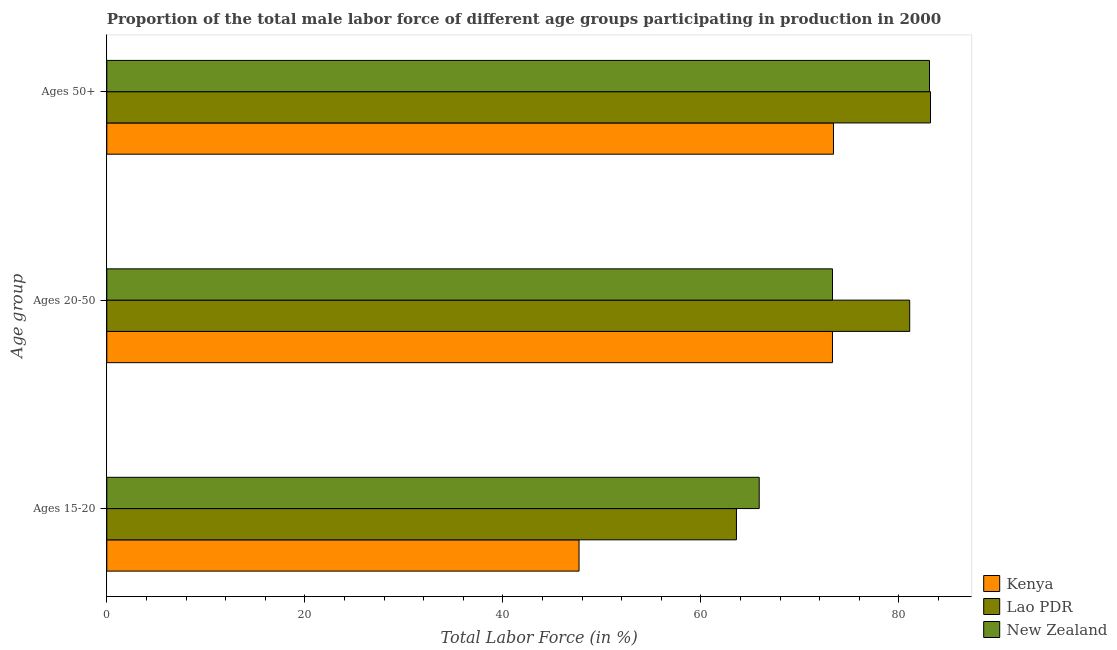How many different coloured bars are there?
Make the answer very short. 3. Are the number of bars per tick equal to the number of legend labels?
Your answer should be very brief. Yes. Are the number of bars on each tick of the Y-axis equal?
Your answer should be compact. Yes. How many bars are there on the 2nd tick from the top?
Ensure brevity in your answer.  3. What is the label of the 3rd group of bars from the top?
Offer a very short reply. Ages 15-20. What is the percentage of male labor force within the age group 15-20 in Lao PDR?
Your answer should be very brief. 63.6. Across all countries, what is the maximum percentage of male labor force above age 50?
Make the answer very short. 83.2. Across all countries, what is the minimum percentage of male labor force above age 50?
Give a very brief answer. 73.4. In which country was the percentage of male labor force within the age group 15-20 maximum?
Provide a succinct answer. New Zealand. In which country was the percentage of male labor force within the age group 15-20 minimum?
Offer a terse response. Kenya. What is the total percentage of male labor force above age 50 in the graph?
Your answer should be compact. 239.7. What is the difference between the percentage of male labor force above age 50 in New Zealand and that in Lao PDR?
Make the answer very short. -0.1. What is the difference between the percentage of male labor force above age 50 in New Zealand and the percentage of male labor force within the age group 15-20 in Kenya?
Provide a short and direct response. 35.4. What is the average percentage of male labor force within the age group 15-20 per country?
Offer a terse response. 59.07. What is the difference between the percentage of male labor force above age 50 and percentage of male labor force within the age group 20-50 in New Zealand?
Your answer should be compact. 9.8. What is the ratio of the percentage of male labor force above age 50 in New Zealand to that in Lao PDR?
Offer a terse response. 1. What is the difference between the highest and the second highest percentage of male labor force above age 50?
Your answer should be very brief. 0.1. What is the difference between the highest and the lowest percentage of male labor force within the age group 20-50?
Ensure brevity in your answer.  7.8. Is the sum of the percentage of male labor force within the age group 20-50 in Lao PDR and Kenya greater than the maximum percentage of male labor force above age 50 across all countries?
Offer a very short reply. Yes. What does the 2nd bar from the top in Ages 20-50 represents?
Offer a very short reply. Lao PDR. What does the 1st bar from the bottom in Ages 20-50 represents?
Keep it short and to the point. Kenya. Is it the case that in every country, the sum of the percentage of male labor force within the age group 15-20 and percentage of male labor force within the age group 20-50 is greater than the percentage of male labor force above age 50?
Provide a succinct answer. Yes. How many bars are there?
Ensure brevity in your answer.  9. Are all the bars in the graph horizontal?
Give a very brief answer. Yes. What is the difference between two consecutive major ticks on the X-axis?
Your answer should be compact. 20. Are the values on the major ticks of X-axis written in scientific E-notation?
Give a very brief answer. No. Does the graph contain any zero values?
Your response must be concise. No. Does the graph contain grids?
Provide a short and direct response. No. Where does the legend appear in the graph?
Ensure brevity in your answer.  Bottom right. How many legend labels are there?
Make the answer very short. 3. How are the legend labels stacked?
Keep it short and to the point. Vertical. What is the title of the graph?
Offer a terse response. Proportion of the total male labor force of different age groups participating in production in 2000. Does "Sub-Saharan Africa (developing only)" appear as one of the legend labels in the graph?
Provide a short and direct response. No. What is the label or title of the Y-axis?
Your answer should be compact. Age group. What is the Total Labor Force (in %) in Kenya in Ages 15-20?
Give a very brief answer. 47.7. What is the Total Labor Force (in %) of Lao PDR in Ages 15-20?
Provide a succinct answer. 63.6. What is the Total Labor Force (in %) of New Zealand in Ages 15-20?
Make the answer very short. 65.9. What is the Total Labor Force (in %) in Kenya in Ages 20-50?
Give a very brief answer. 73.3. What is the Total Labor Force (in %) of Lao PDR in Ages 20-50?
Keep it short and to the point. 81.1. What is the Total Labor Force (in %) of New Zealand in Ages 20-50?
Provide a short and direct response. 73.3. What is the Total Labor Force (in %) of Kenya in Ages 50+?
Make the answer very short. 73.4. What is the Total Labor Force (in %) in Lao PDR in Ages 50+?
Provide a short and direct response. 83.2. What is the Total Labor Force (in %) of New Zealand in Ages 50+?
Provide a short and direct response. 83.1. Across all Age group, what is the maximum Total Labor Force (in %) of Kenya?
Keep it short and to the point. 73.4. Across all Age group, what is the maximum Total Labor Force (in %) of Lao PDR?
Provide a succinct answer. 83.2. Across all Age group, what is the maximum Total Labor Force (in %) in New Zealand?
Keep it short and to the point. 83.1. Across all Age group, what is the minimum Total Labor Force (in %) in Kenya?
Your answer should be very brief. 47.7. Across all Age group, what is the minimum Total Labor Force (in %) in Lao PDR?
Your answer should be very brief. 63.6. Across all Age group, what is the minimum Total Labor Force (in %) of New Zealand?
Keep it short and to the point. 65.9. What is the total Total Labor Force (in %) of Kenya in the graph?
Give a very brief answer. 194.4. What is the total Total Labor Force (in %) in Lao PDR in the graph?
Provide a short and direct response. 227.9. What is the total Total Labor Force (in %) in New Zealand in the graph?
Your response must be concise. 222.3. What is the difference between the Total Labor Force (in %) of Kenya in Ages 15-20 and that in Ages 20-50?
Make the answer very short. -25.6. What is the difference between the Total Labor Force (in %) in Lao PDR in Ages 15-20 and that in Ages 20-50?
Make the answer very short. -17.5. What is the difference between the Total Labor Force (in %) of New Zealand in Ages 15-20 and that in Ages 20-50?
Keep it short and to the point. -7.4. What is the difference between the Total Labor Force (in %) of Kenya in Ages 15-20 and that in Ages 50+?
Your answer should be compact. -25.7. What is the difference between the Total Labor Force (in %) of Lao PDR in Ages 15-20 and that in Ages 50+?
Offer a terse response. -19.6. What is the difference between the Total Labor Force (in %) in New Zealand in Ages 15-20 and that in Ages 50+?
Provide a succinct answer. -17.2. What is the difference between the Total Labor Force (in %) in Kenya in Ages 15-20 and the Total Labor Force (in %) in Lao PDR in Ages 20-50?
Make the answer very short. -33.4. What is the difference between the Total Labor Force (in %) in Kenya in Ages 15-20 and the Total Labor Force (in %) in New Zealand in Ages 20-50?
Ensure brevity in your answer.  -25.6. What is the difference between the Total Labor Force (in %) of Lao PDR in Ages 15-20 and the Total Labor Force (in %) of New Zealand in Ages 20-50?
Give a very brief answer. -9.7. What is the difference between the Total Labor Force (in %) in Kenya in Ages 15-20 and the Total Labor Force (in %) in Lao PDR in Ages 50+?
Ensure brevity in your answer.  -35.5. What is the difference between the Total Labor Force (in %) in Kenya in Ages 15-20 and the Total Labor Force (in %) in New Zealand in Ages 50+?
Keep it short and to the point. -35.4. What is the difference between the Total Labor Force (in %) of Lao PDR in Ages 15-20 and the Total Labor Force (in %) of New Zealand in Ages 50+?
Make the answer very short. -19.5. What is the difference between the Total Labor Force (in %) of Kenya in Ages 20-50 and the Total Labor Force (in %) of Lao PDR in Ages 50+?
Provide a short and direct response. -9.9. What is the average Total Labor Force (in %) of Kenya per Age group?
Provide a succinct answer. 64.8. What is the average Total Labor Force (in %) in Lao PDR per Age group?
Offer a very short reply. 75.97. What is the average Total Labor Force (in %) of New Zealand per Age group?
Your response must be concise. 74.1. What is the difference between the Total Labor Force (in %) in Kenya and Total Labor Force (in %) in Lao PDR in Ages 15-20?
Your response must be concise. -15.9. What is the difference between the Total Labor Force (in %) in Kenya and Total Labor Force (in %) in New Zealand in Ages 15-20?
Provide a short and direct response. -18.2. What is the difference between the Total Labor Force (in %) of Lao PDR and Total Labor Force (in %) of New Zealand in Ages 15-20?
Provide a short and direct response. -2.3. What is the difference between the Total Labor Force (in %) in Kenya and Total Labor Force (in %) in New Zealand in Ages 20-50?
Your response must be concise. 0. What is the difference between the Total Labor Force (in %) in Lao PDR and Total Labor Force (in %) in New Zealand in Ages 20-50?
Provide a succinct answer. 7.8. What is the difference between the Total Labor Force (in %) of Kenya and Total Labor Force (in %) of New Zealand in Ages 50+?
Keep it short and to the point. -9.7. What is the difference between the Total Labor Force (in %) in Lao PDR and Total Labor Force (in %) in New Zealand in Ages 50+?
Provide a succinct answer. 0.1. What is the ratio of the Total Labor Force (in %) in Kenya in Ages 15-20 to that in Ages 20-50?
Your response must be concise. 0.65. What is the ratio of the Total Labor Force (in %) of Lao PDR in Ages 15-20 to that in Ages 20-50?
Provide a short and direct response. 0.78. What is the ratio of the Total Labor Force (in %) in New Zealand in Ages 15-20 to that in Ages 20-50?
Provide a short and direct response. 0.9. What is the ratio of the Total Labor Force (in %) in Kenya in Ages 15-20 to that in Ages 50+?
Keep it short and to the point. 0.65. What is the ratio of the Total Labor Force (in %) in Lao PDR in Ages 15-20 to that in Ages 50+?
Ensure brevity in your answer.  0.76. What is the ratio of the Total Labor Force (in %) in New Zealand in Ages 15-20 to that in Ages 50+?
Your response must be concise. 0.79. What is the ratio of the Total Labor Force (in %) in Kenya in Ages 20-50 to that in Ages 50+?
Offer a very short reply. 1. What is the ratio of the Total Labor Force (in %) in Lao PDR in Ages 20-50 to that in Ages 50+?
Offer a terse response. 0.97. What is the ratio of the Total Labor Force (in %) of New Zealand in Ages 20-50 to that in Ages 50+?
Your answer should be very brief. 0.88. What is the difference between the highest and the second highest Total Labor Force (in %) in Kenya?
Provide a short and direct response. 0.1. What is the difference between the highest and the second highest Total Labor Force (in %) of Lao PDR?
Provide a succinct answer. 2.1. What is the difference between the highest and the second highest Total Labor Force (in %) in New Zealand?
Your response must be concise. 9.8. What is the difference between the highest and the lowest Total Labor Force (in %) of Kenya?
Offer a terse response. 25.7. What is the difference between the highest and the lowest Total Labor Force (in %) in Lao PDR?
Your answer should be compact. 19.6. What is the difference between the highest and the lowest Total Labor Force (in %) in New Zealand?
Your answer should be very brief. 17.2. 